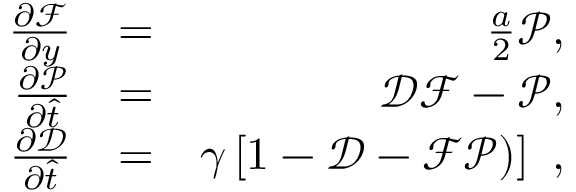Convert formula to latex. <formula><loc_0><loc_0><loc_500><loc_500>\begin{array} { r l r } { \frac { \partial \mathcal { F } } { \partial y } } & { = } & { \frac { a } { 2 } \mathcal { P } , } \\ { \frac { \partial \mathcal { P } } { \partial \hat { t } } } & { = } & { \mathcal { D } \mathcal { F } - \mathcal { P } , } \\ { \frac { \partial \mathcal { D } } { \partial \hat { t } } } & { = } & { \gamma \left [ 1 - \mathcal { D } - \mathcal { F } \mathcal { P } ) \right ] , } \end{array}</formula> 